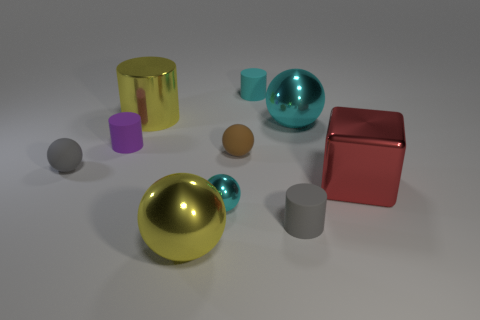Is the number of red blocks in front of the tiny cyan metal object greater than the number of big yellow metallic balls that are behind the gray matte cylinder?
Your response must be concise. No. The purple matte object that is the same shape as the cyan matte thing is what size?
Offer a very short reply. Small. How many spheres are tiny green metallic things or yellow shiny objects?
Give a very brief answer. 1. What is the material of the thing that is the same color as the shiny cylinder?
Your answer should be very brief. Metal. Are there fewer tiny things left of the small purple cylinder than cyan metal spheres that are to the right of the big yellow ball?
Keep it short and to the point. Yes. What number of things are either metal objects that are in front of the brown matte object or tiny rubber cylinders?
Ensure brevity in your answer.  6. What is the shape of the tiny cyan thing that is in front of the large cylinder left of the cyan cylinder?
Provide a succinct answer. Sphere. Is there a cyan ball of the same size as the yellow shiny cylinder?
Offer a very short reply. Yes. Is the number of tiny cyan rubber cylinders greater than the number of large red matte cylinders?
Ensure brevity in your answer.  Yes. Do the gray matte ball left of the purple matte cylinder and the yellow shiny object in front of the small purple matte thing have the same size?
Offer a terse response. No. 